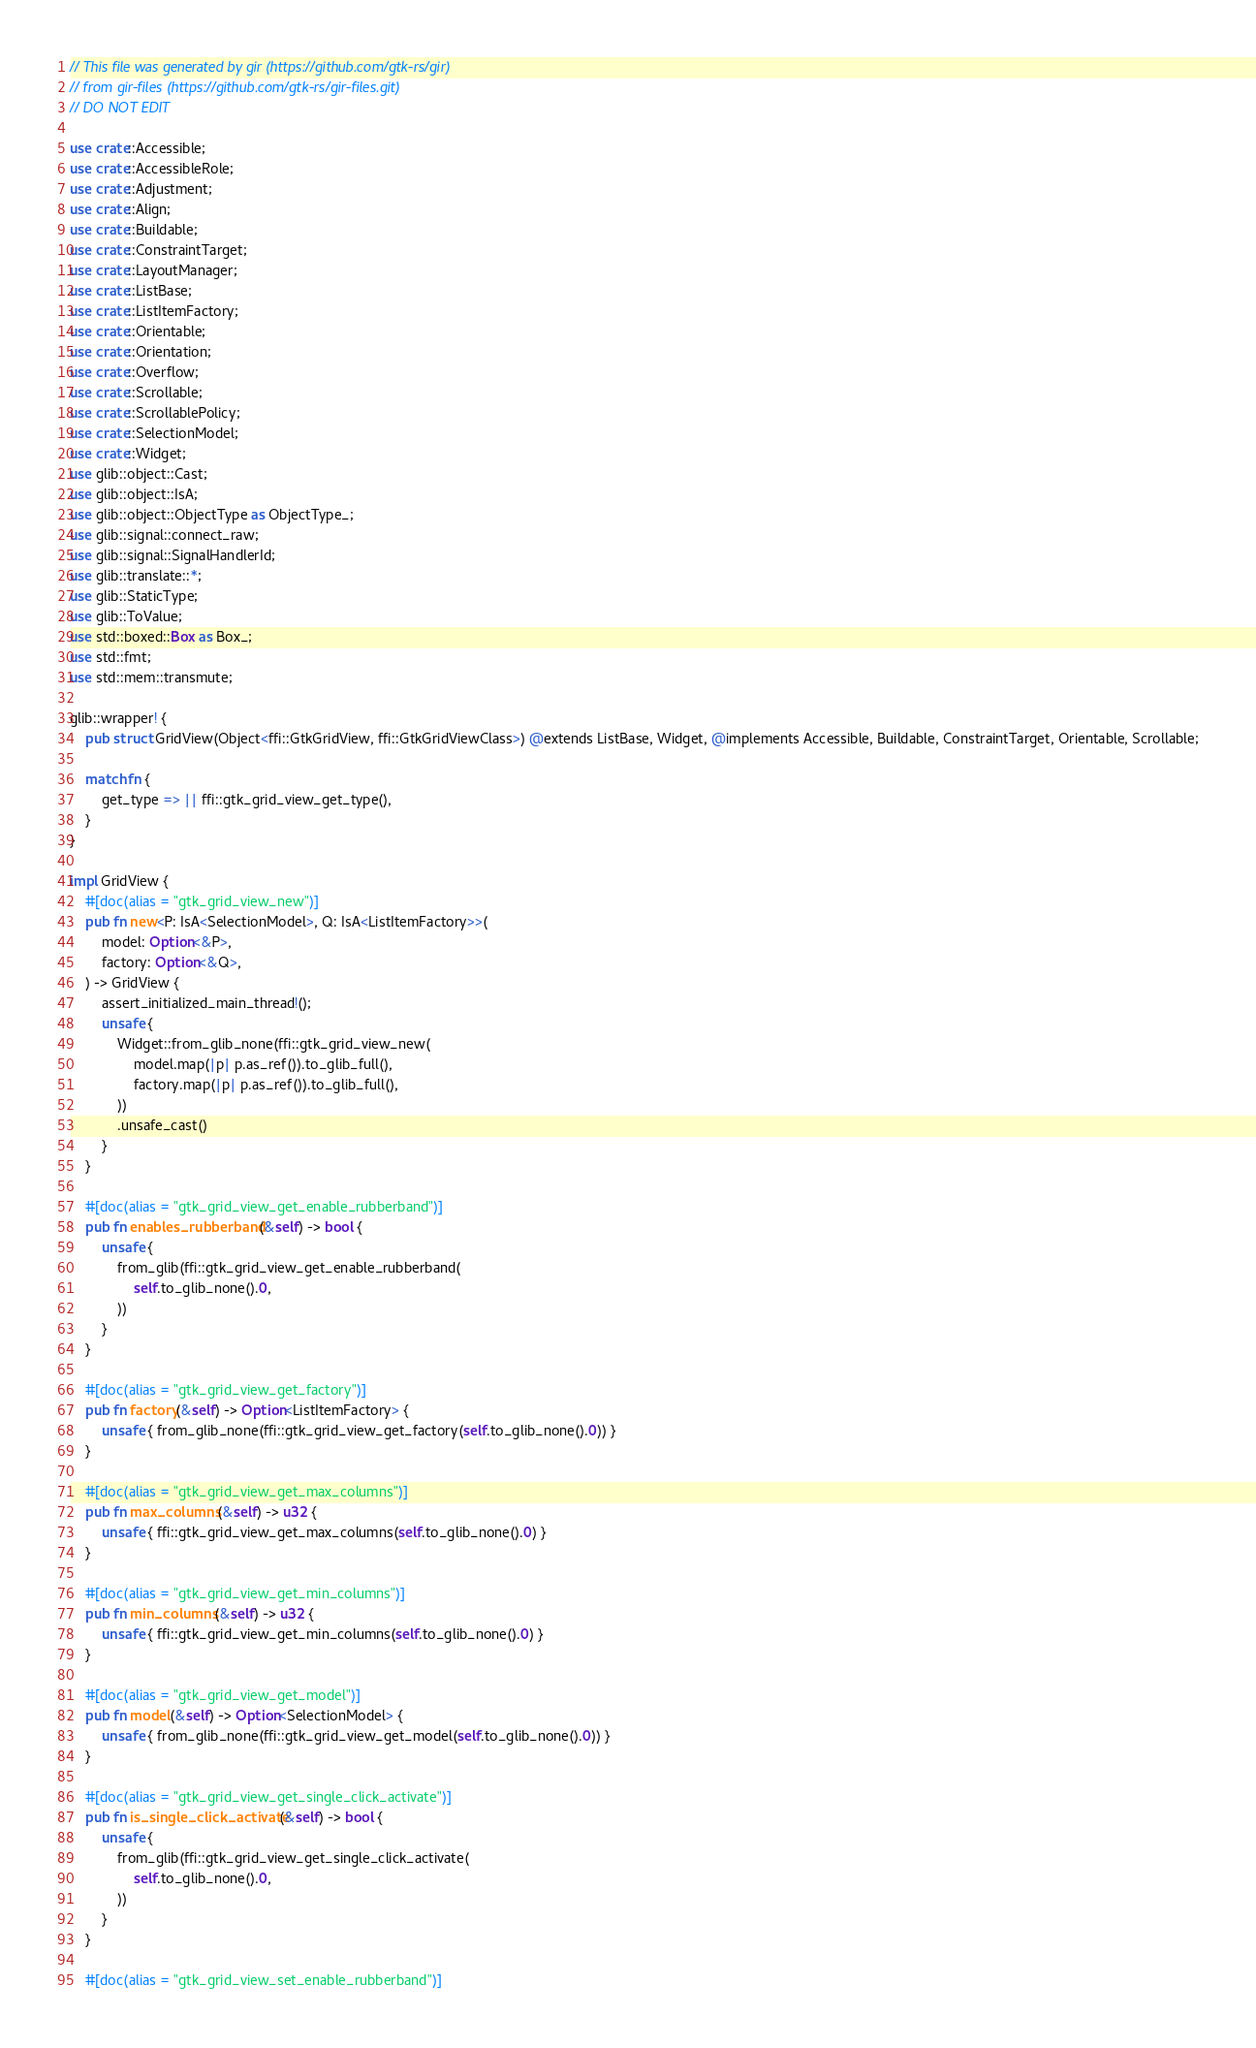<code> <loc_0><loc_0><loc_500><loc_500><_Rust_>// This file was generated by gir (https://github.com/gtk-rs/gir)
// from gir-files (https://github.com/gtk-rs/gir-files.git)
// DO NOT EDIT

use crate::Accessible;
use crate::AccessibleRole;
use crate::Adjustment;
use crate::Align;
use crate::Buildable;
use crate::ConstraintTarget;
use crate::LayoutManager;
use crate::ListBase;
use crate::ListItemFactory;
use crate::Orientable;
use crate::Orientation;
use crate::Overflow;
use crate::Scrollable;
use crate::ScrollablePolicy;
use crate::SelectionModel;
use crate::Widget;
use glib::object::Cast;
use glib::object::IsA;
use glib::object::ObjectType as ObjectType_;
use glib::signal::connect_raw;
use glib::signal::SignalHandlerId;
use glib::translate::*;
use glib::StaticType;
use glib::ToValue;
use std::boxed::Box as Box_;
use std::fmt;
use std::mem::transmute;

glib::wrapper! {
    pub struct GridView(Object<ffi::GtkGridView, ffi::GtkGridViewClass>) @extends ListBase, Widget, @implements Accessible, Buildable, ConstraintTarget, Orientable, Scrollable;

    match fn {
        get_type => || ffi::gtk_grid_view_get_type(),
    }
}

impl GridView {
    #[doc(alias = "gtk_grid_view_new")]
    pub fn new<P: IsA<SelectionModel>, Q: IsA<ListItemFactory>>(
        model: Option<&P>,
        factory: Option<&Q>,
    ) -> GridView {
        assert_initialized_main_thread!();
        unsafe {
            Widget::from_glib_none(ffi::gtk_grid_view_new(
                model.map(|p| p.as_ref()).to_glib_full(),
                factory.map(|p| p.as_ref()).to_glib_full(),
            ))
            .unsafe_cast()
        }
    }

    #[doc(alias = "gtk_grid_view_get_enable_rubberband")]
    pub fn enables_rubberband(&self) -> bool {
        unsafe {
            from_glib(ffi::gtk_grid_view_get_enable_rubberband(
                self.to_glib_none().0,
            ))
        }
    }

    #[doc(alias = "gtk_grid_view_get_factory")]
    pub fn factory(&self) -> Option<ListItemFactory> {
        unsafe { from_glib_none(ffi::gtk_grid_view_get_factory(self.to_glib_none().0)) }
    }

    #[doc(alias = "gtk_grid_view_get_max_columns")]
    pub fn max_columns(&self) -> u32 {
        unsafe { ffi::gtk_grid_view_get_max_columns(self.to_glib_none().0) }
    }

    #[doc(alias = "gtk_grid_view_get_min_columns")]
    pub fn min_columns(&self) -> u32 {
        unsafe { ffi::gtk_grid_view_get_min_columns(self.to_glib_none().0) }
    }

    #[doc(alias = "gtk_grid_view_get_model")]
    pub fn model(&self) -> Option<SelectionModel> {
        unsafe { from_glib_none(ffi::gtk_grid_view_get_model(self.to_glib_none().0)) }
    }

    #[doc(alias = "gtk_grid_view_get_single_click_activate")]
    pub fn is_single_click_activate(&self) -> bool {
        unsafe {
            from_glib(ffi::gtk_grid_view_get_single_click_activate(
                self.to_glib_none().0,
            ))
        }
    }

    #[doc(alias = "gtk_grid_view_set_enable_rubberband")]</code> 